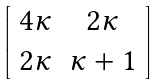<formula> <loc_0><loc_0><loc_500><loc_500>\left [ \begin{array} { c c } 4 \kappa & 2 \kappa \\ 2 \kappa & \kappa + 1 \end{array} \right ]</formula> 